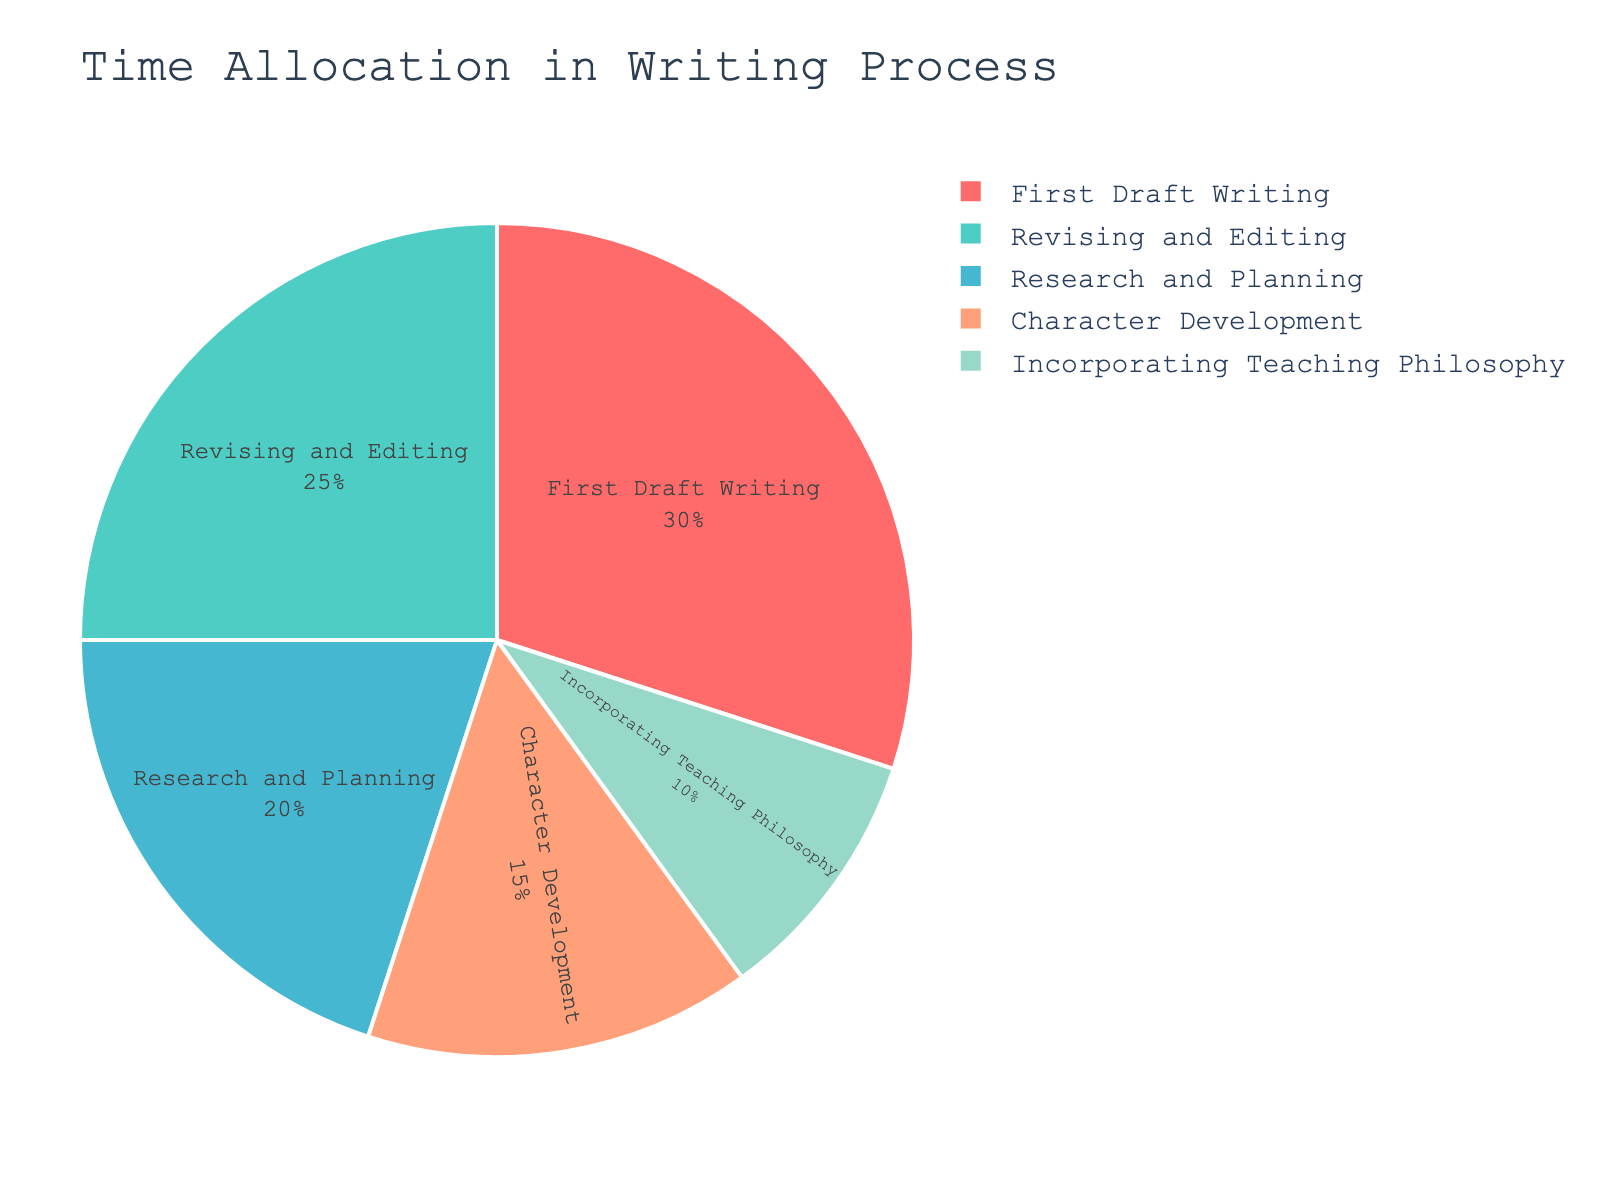Which stage takes the most significant percentage of time? Look at the pie chart, identify the segment with the largest percentage label, which represents 'First Draft Writing' at 30%.
Answer: First Draft Writing What's the combined time percentage spent on 'Research and Planning' and 'Revising and Editing'? Add the percentages of 'Research and Planning' (20%) and 'Revising and Editing' (25%) together: 20% + 25% = 45%.
Answer: 45% Which stage is represented by the red color in the pie chart? Identify the segment colored in red and look at its label, which is 'Research and Planning'.
Answer: Research and Planning How much more time is allocated to 'First Draft Writing' compared to 'Character Development'? Subtract the percentage of 'Character Development' (15%) from 'First Draft Writing' (30%): 30% - 15% = 15%.
Answer: 15% Is the time spent on 'Incorporating Teaching Philosophy' more or less than 'Character Development'? Compare the percentages of 'Incorporating Teaching Philosophy' (10%) and 'Character Development' (15%); 10% is less than 15%.
Answer: Less What is the total percentage of time spent on stages other than 'First Draft Writing'? Sum the percentages of all stages except 'First Draft Writing' (20% + 15% + 25% + 10%): 20% + 15% + 25% + 10% = 70%.
Answer: 70% Which two stages together sum up to the same percentage as 'First Draft Writing'? Identify two stages that when combined equal 30%; 'Research and Planning' (20%) and 'Incorporating Teaching Philosophy' (10%) sum is 20% + 10% = 30%.
Answer: Research and Planning, Incorporating Teaching Philosophy What is the difference in time spent on 'Revising and Editing' versus 'Research and Planning'? Subtract the percentage of 'Research and Planning' (20%) from 'Revising and Editing' (25%): 25% - 20% = 5%.
Answer: 5% Is the time spent on 'Character Development' more than twice the time allocated to 'Incorporating Teaching Philosophy'? Compare 'Character Development' percentage (15%) with twice 'Incorporating Teaching Philosophy' percentage (10% * 2 = 20%); 15% is less than 20%.
Answer: No 